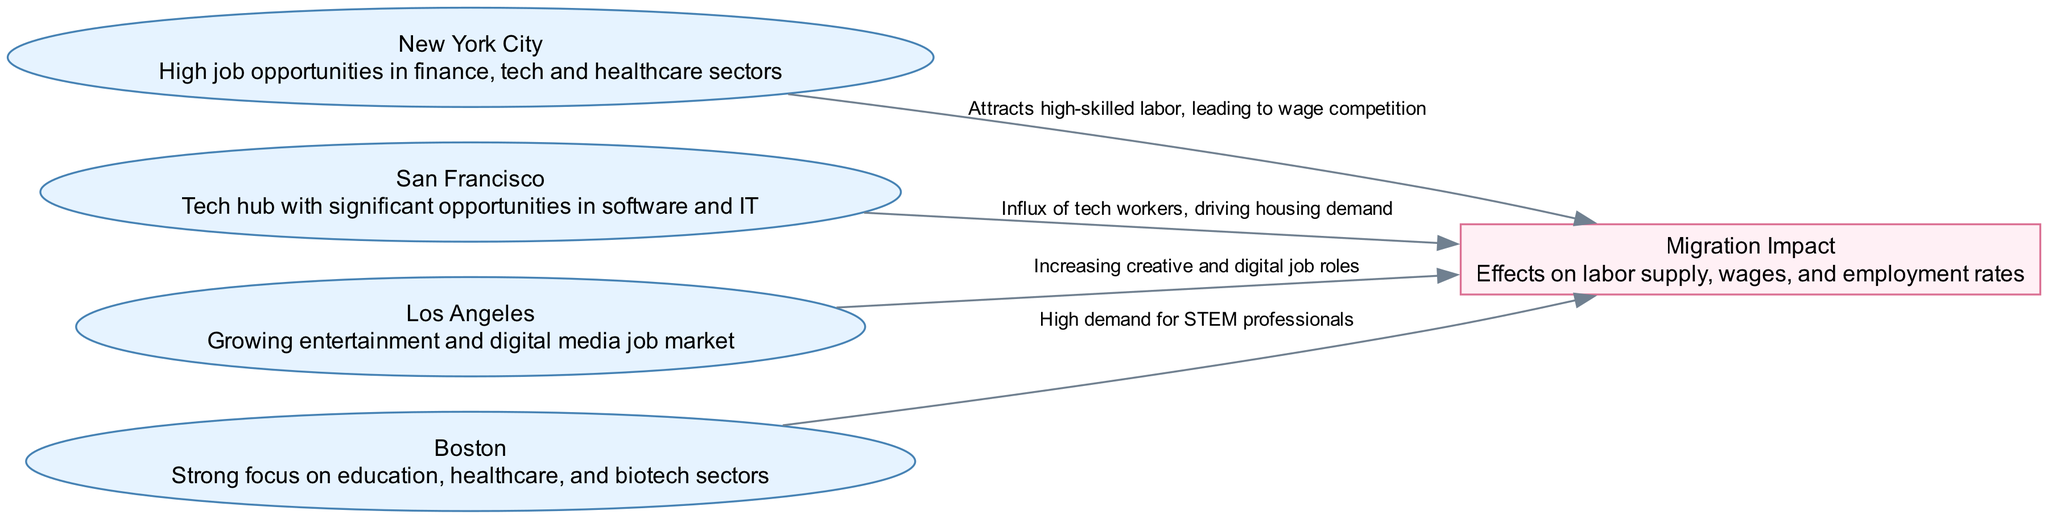What are the major cities represented in the diagram? The diagram displays four major cities: New York City, San Francisco, Los Angeles, and Boston. Each city is denoted as a node and is relevant for understanding migration patterns.
Answer: New York City, San Francisco, Los Angeles, Boston How many edges are there in the diagram? The diagram contains four edges, each representing the relationship between a city and the impact of migration. Each edge connects a city node to the concept node of Migration Impact.
Answer: 4 What is the main effect of migration from San Francisco? The edge from San Francisco to Migration Impact states that there is an influx of tech workers driving housing demand. This indicates how migration affects local market conditions related to housing.
Answer: Driving housing demand Which city is associated with high demand for STEM professionals? The node for Boston mentions a strong focus on education and high demand for STEM professionals, highlighting its specific labor market characteristics. This connection is evident in the diagram through the edge to Migration Impact.
Answer: Boston What common theme is shared by all cities in relation to Migration Impact? All four cities contribute to the Migration Impact in terms of attracting skilled labor, which is particularly noted as leading to wage competition, increasing job roles, and driving housing demand. This illustrates a shared dynamic within the labor market.
Answer: Attracting skilled labor Which city is indicated as a tech hub? The diagram specifies San Francisco as the tech hub, indicating its significance regarding job opportunities in software and IT. This distinction is visually marked within the node description.
Answer: San Francisco What type of jobs is Los Angeles growing in? The edge connecting Los Angeles to Migration Impact indicates that the city is experiencing an increase in creative and digital job roles, reflecting its growth in that sector.
Answer: Creative and digital job roles What does migration from New York City lead to? The edge from New York City to Migration Impact illustrates that it attracts high-skilled labor, resulting in wage competition, which is a competitive dynamic within its labor market.
Answer: Wage competition 